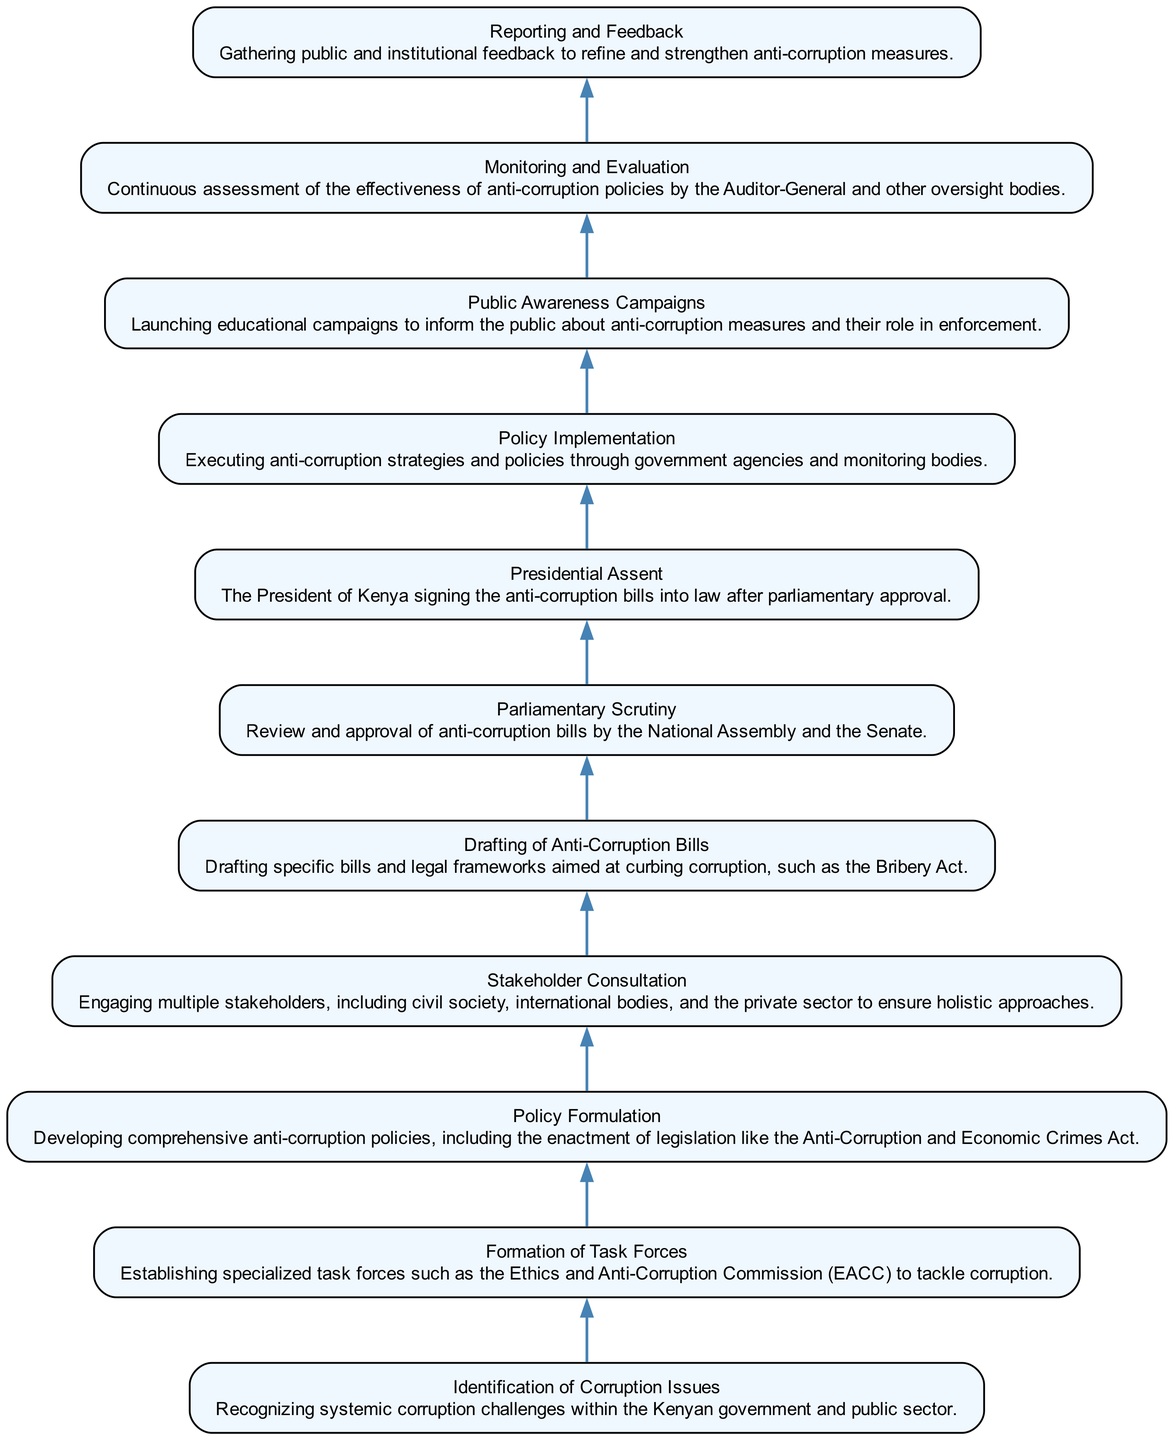What is the first step in the anti-corruption policy development? The first step is "Identification of Corruption Issues," which addresses systemic challenges in the Kenyan government.
Answer: Identification of Corruption Issues How many nodes are present in the diagram? The total number of nodes corresponds to the number of elements listed, which is eleven in this case.
Answer: 11 What follows after "Formation of Task Forces"? The next step after "Formation of Task Forces" is "Policy Formulation," where comprehensive anti-corruption policies are developed.
Answer: Policy Formulation Which node represents the final stage of the policy process? The final stage of the policy process is represented by "Reporting and Feedback," where public feedback is gathered to refine measures.
Answer: Reporting and Feedback Which two stages occur before the "Policy Implementation"? The two stages that occur before "Policy Implementation" are "Presidential Assent" and "Parliamentary Scrutiny."
Answer: Presidential Assent and Parliamentary Scrutiny What is the purpose of "Stakeholder Consultation"? The purpose of "Stakeholder Consultation" is to engage various stakeholders, including civil society and international bodies, for a holistic approach.
Answer: To engage multiple stakeholders What is the relationship between "Drafting of Anti-Corruption Bills" and "Parliamentary Scrutiny"? "Drafting of Anti-Corruption Bills" leads directly to "Parliamentary Scrutiny," where the bills are reviewed and approved.
Answer: Directly leads to What comes right after "Public Awareness Campaigns"? "Monitoring and Evaluation" comes right after "Public Awareness Campaigns" to assess the effectiveness of the policies.
Answer: Monitoring and Evaluation What does the "Monitoring and Evaluation" node ensure? "Monitoring and Evaluation" ensures continuous assessment of the effectiveness of anti-corruption policies.
Answer: Continuous assessment of effectiveness 